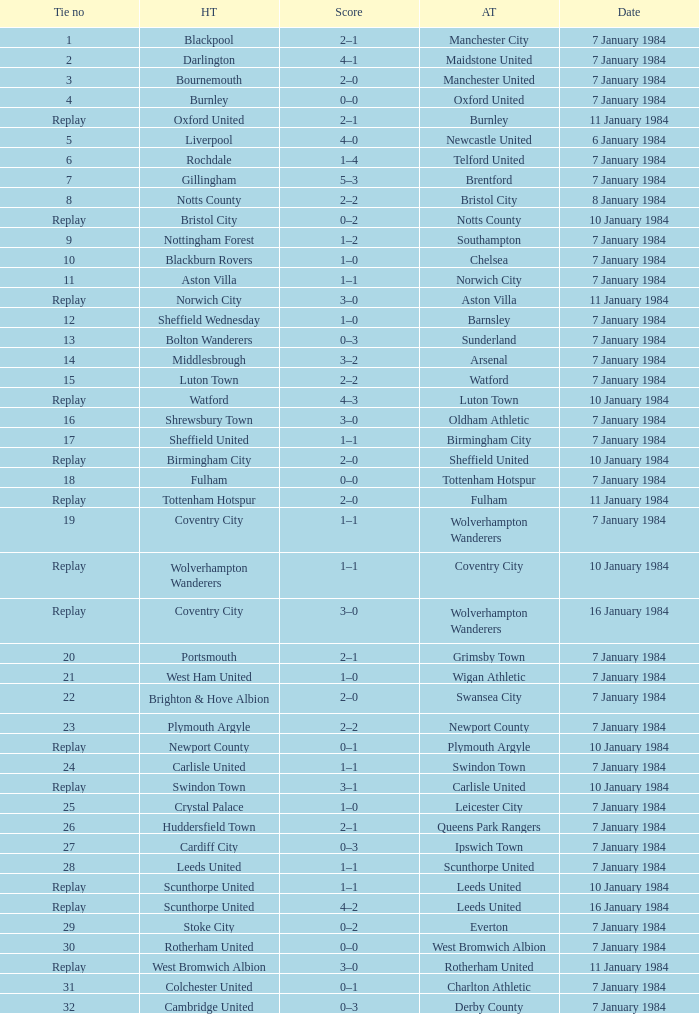Who was the away team with a tie of 14? Arsenal. 